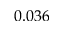<formula> <loc_0><loc_0><loc_500><loc_500>0 . 0 3 6</formula> 